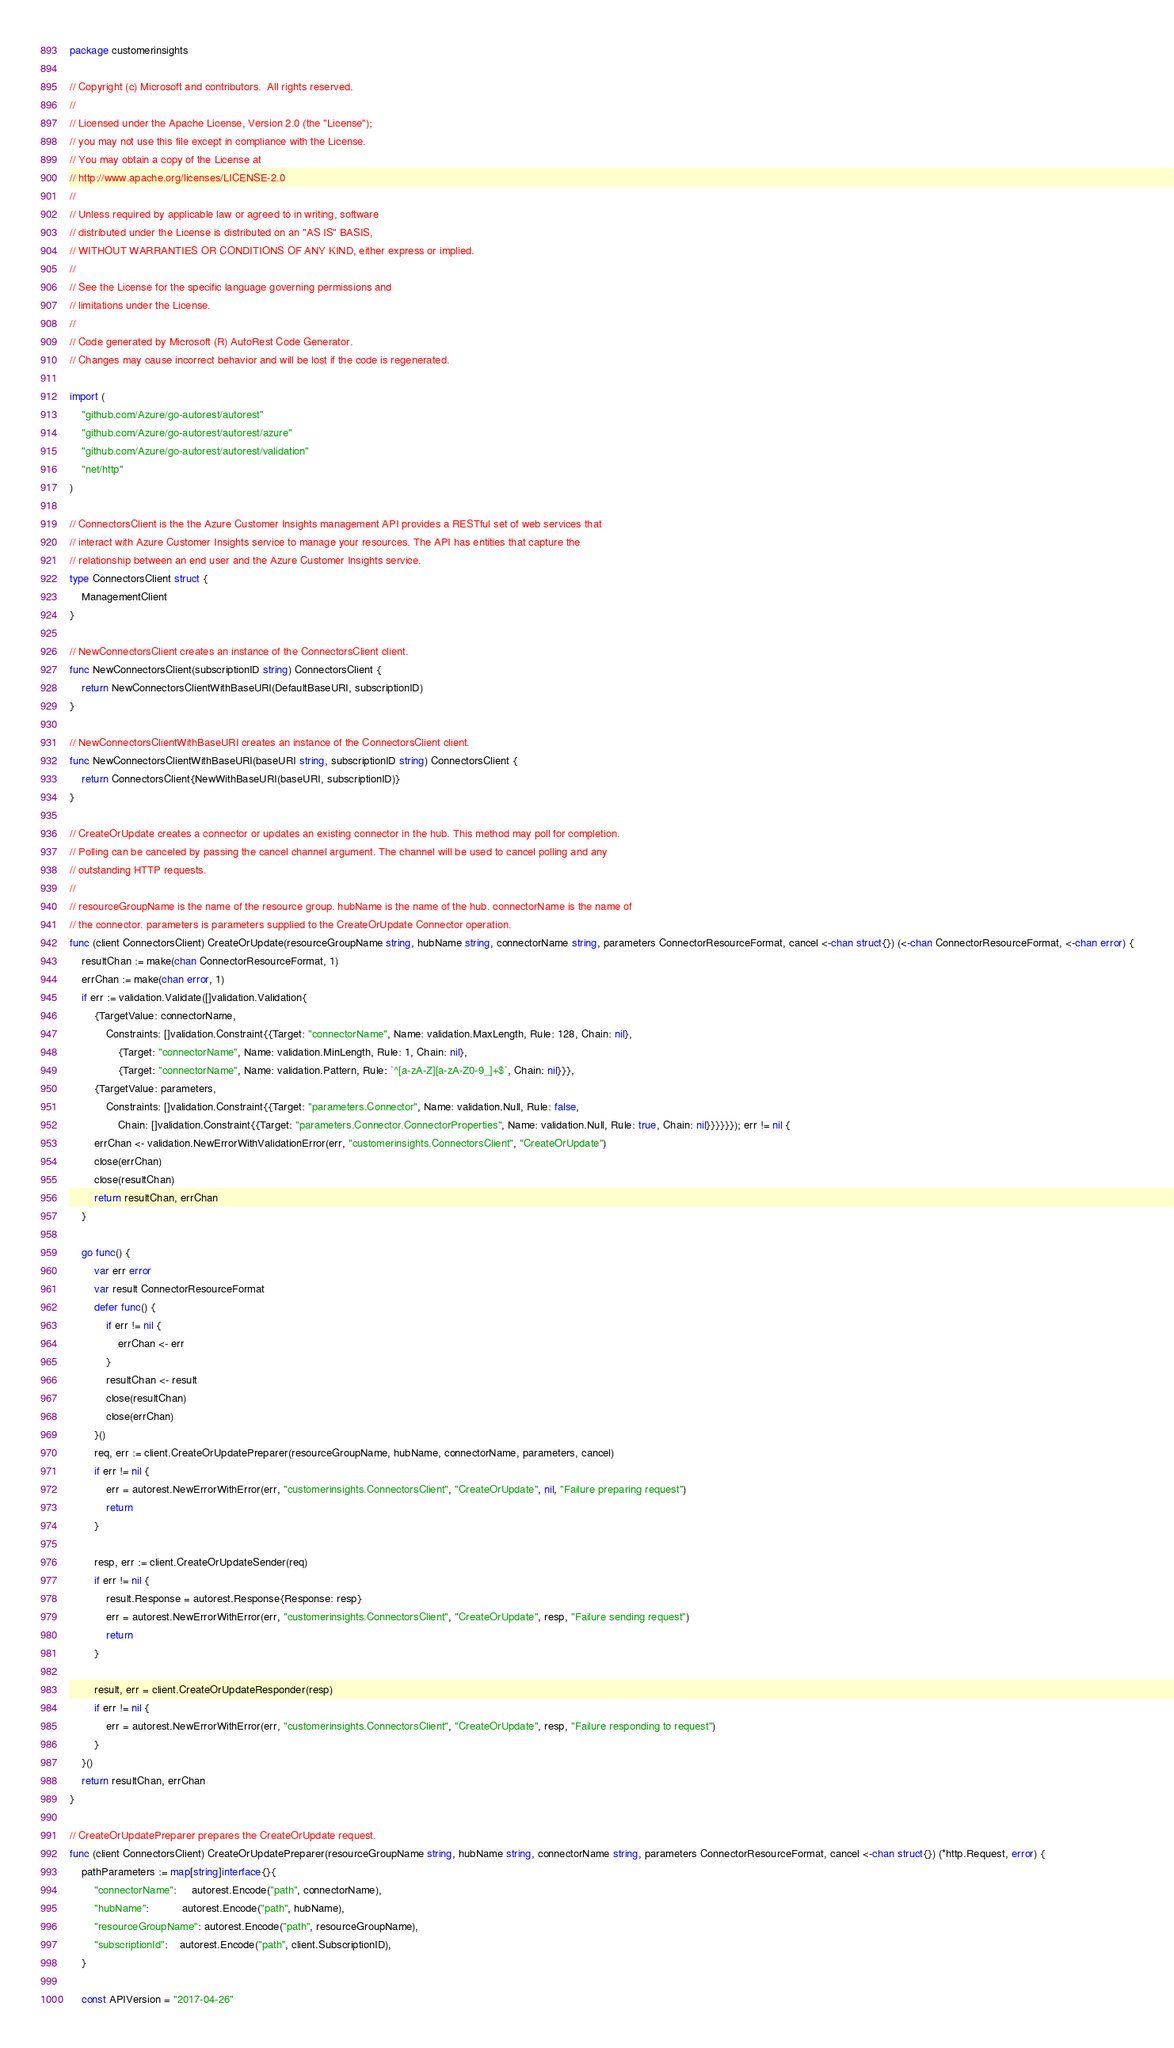Convert code to text. <code><loc_0><loc_0><loc_500><loc_500><_Go_>package customerinsights

// Copyright (c) Microsoft and contributors.  All rights reserved.
//
// Licensed under the Apache License, Version 2.0 (the "License");
// you may not use this file except in compliance with the License.
// You may obtain a copy of the License at
// http://www.apache.org/licenses/LICENSE-2.0
//
// Unless required by applicable law or agreed to in writing, software
// distributed under the License is distributed on an "AS IS" BASIS,
// WITHOUT WARRANTIES OR CONDITIONS OF ANY KIND, either express or implied.
//
// See the License for the specific language governing permissions and
// limitations under the License.
//
// Code generated by Microsoft (R) AutoRest Code Generator.
// Changes may cause incorrect behavior and will be lost if the code is regenerated.

import (
	"github.com/Azure/go-autorest/autorest"
	"github.com/Azure/go-autorest/autorest/azure"
	"github.com/Azure/go-autorest/autorest/validation"
	"net/http"
)

// ConnectorsClient is the the Azure Customer Insights management API provides a RESTful set of web services that
// interact with Azure Customer Insights service to manage your resources. The API has entities that capture the
// relationship between an end user and the Azure Customer Insights service.
type ConnectorsClient struct {
	ManagementClient
}

// NewConnectorsClient creates an instance of the ConnectorsClient client.
func NewConnectorsClient(subscriptionID string) ConnectorsClient {
	return NewConnectorsClientWithBaseURI(DefaultBaseURI, subscriptionID)
}

// NewConnectorsClientWithBaseURI creates an instance of the ConnectorsClient client.
func NewConnectorsClientWithBaseURI(baseURI string, subscriptionID string) ConnectorsClient {
	return ConnectorsClient{NewWithBaseURI(baseURI, subscriptionID)}
}

// CreateOrUpdate creates a connector or updates an existing connector in the hub. This method may poll for completion.
// Polling can be canceled by passing the cancel channel argument. The channel will be used to cancel polling and any
// outstanding HTTP requests.
//
// resourceGroupName is the name of the resource group. hubName is the name of the hub. connectorName is the name of
// the connector. parameters is parameters supplied to the CreateOrUpdate Connector operation.
func (client ConnectorsClient) CreateOrUpdate(resourceGroupName string, hubName string, connectorName string, parameters ConnectorResourceFormat, cancel <-chan struct{}) (<-chan ConnectorResourceFormat, <-chan error) {
	resultChan := make(chan ConnectorResourceFormat, 1)
	errChan := make(chan error, 1)
	if err := validation.Validate([]validation.Validation{
		{TargetValue: connectorName,
			Constraints: []validation.Constraint{{Target: "connectorName", Name: validation.MaxLength, Rule: 128, Chain: nil},
				{Target: "connectorName", Name: validation.MinLength, Rule: 1, Chain: nil},
				{Target: "connectorName", Name: validation.Pattern, Rule: `^[a-zA-Z][a-zA-Z0-9_]+$`, Chain: nil}}},
		{TargetValue: parameters,
			Constraints: []validation.Constraint{{Target: "parameters.Connector", Name: validation.Null, Rule: false,
				Chain: []validation.Constraint{{Target: "parameters.Connector.ConnectorProperties", Name: validation.Null, Rule: true, Chain: nil}}}}}}); err != nil {
		errChan <- validation.NewErrorWithValidationError(err, "customerinsights.ConnectorsClient", "CreateOrUpdate")
		close(errChan)
		close(resultChan)
		return resultChan, errChan
	}

	go func() {
		var err error
		var result ConnectorResourceFormat
		defer func() {
			if err != nil {
				errChan <- err
			}
			resultChan <- result
			close(resultChan)
			close(errChan)
		}()
		req, err := client.CreateOrUpdatePreparer(resourceGroupName, hubName, connectorName, parameters, cancel)
		if err != nil {
			err = autorest.NewErrorWithError(err, "customerinsights.ConnectorsClient", "CreateOrUpdate", nil, "Failure preparing request")
			return
		}

		resp, err := client.CreateOrUpdateSender(req)
		if err != nil {
			result.Response = autorest.Response{Response: resp}
			err = autorest.NewErrorWithError(err, "customerinsights.ConnectorsClient", "CreateOrUpdate", resp, "Failure sending request")
			return
		}

		result, err = client.CreateOrUpdateResponder(resp)
		if err != nil {
			err = autorest.NewErrorWithError(err, "customerinsights.ConnectorsClient", "CreateOrUpdate", resp, "Failure responding to request")
		}
	}()
	return resultChan, errChan
}

// CreateOrUpdatePreparer prepares the CreateOrUpdate request.
func (client ConnectorsClient) CreateOrUpdatePreparer(resourceGroupName string, hubName string, connectorName string, parameters ConnectorResourceFormat, cancel <-chan struct{}) (*http.Request, error) {
	pathParameters := map[string]interface{}{
		"connectorName":     autorest.Encode("path", connectorName),
		"hubName":           autorest.Encode("path", hubName),
		"resourceGroupName": autorest.Encode("path", resourceGroupName),
		"subscriptionId":    autorest.Encode("path", client.SubscriptionID),
	}

	const APIVersion = "2017-04-26"</code> 